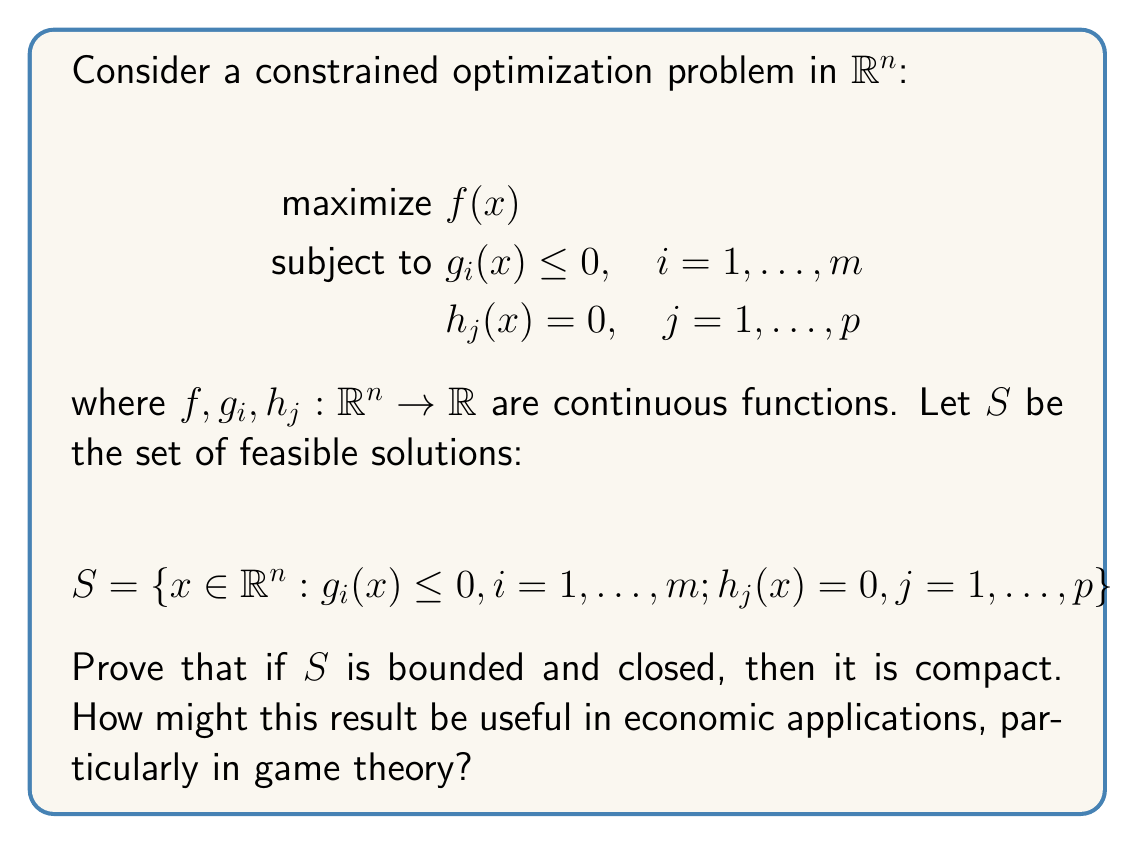Can you solve this math problem? To prove that the set of feasible solutions $S$ is compact, we need to show that it is both closed and bounded in $\mathbb{R}^n$. We are given that $S$ is bounded and closed, so we just need to apply the Heine-Borel theorem to conclude that $S$ is compact. Here's a step-by-step explanation:

1) Closedness of $S$:
   The set $S$ is defined by a finite number of inequality and equality constraints involving continuous functions. Each constraint defines a closed set:
   - For $g_i(x) \leq 0$, the set $\{x : g_i(x) \leq 0\}$ is closed because $g_i$ is continuous.
   - For $h_j(x) = 0$, the set $\{x : h_j(x) = 0\}$ is closed because $h_j$ is continuous.
   
   $S$ is the intersection of these closed sets, and a finite intersection of closed sets is closed.

2) Boundedness of $S$:
   We are given that $S$ is bounded.

3) Heine-Borel theorem:
   In $\mathbb{R}^n$, a set is compact if and only if it is closed and bounded.

4) Conclusion:
   Since $S$ is both closed and bounded in $\mathbb{R}^n$, by the Heine-Borel theorem, $S$ is compact.

Economic applications, particularly in game theory:

a) Nash Equilibrium: In game theory, the strategy space of each player can be represented as a compact set. The compactness of the strategy space is crucial for proving the existence of Nash equilibria using fixed-point theorems like Kakutani's fixed-point theorem.

b) Optimization in Economics: Many economic problems involve maximizing or minimizing functions over compact sets. The extreme value theorem guarantees that a continuous function on a compact set attains its maximum and minimum, which is essential for solving optimization problems in economics.

c) Equilibrium Analysis: In general equilibrium theory, the set of feasible allocations is often compact. This property is used to prove the existence of competitive equilibria.

d) Dynamic Programming: In dynamic economic models, the state space is often assumed to be compact. This assumption simplifies the analysis and helps in proving the existence and uniqueness of value functions.
Answer: The set of feasible solutions $S$ is compact because it is closed and bounded in $\mathbb{R}^n$, and by the Heine-Borel theorem, a subset of $\mathbb{R}^n$ is compact if and only if it is closed and bounded. 